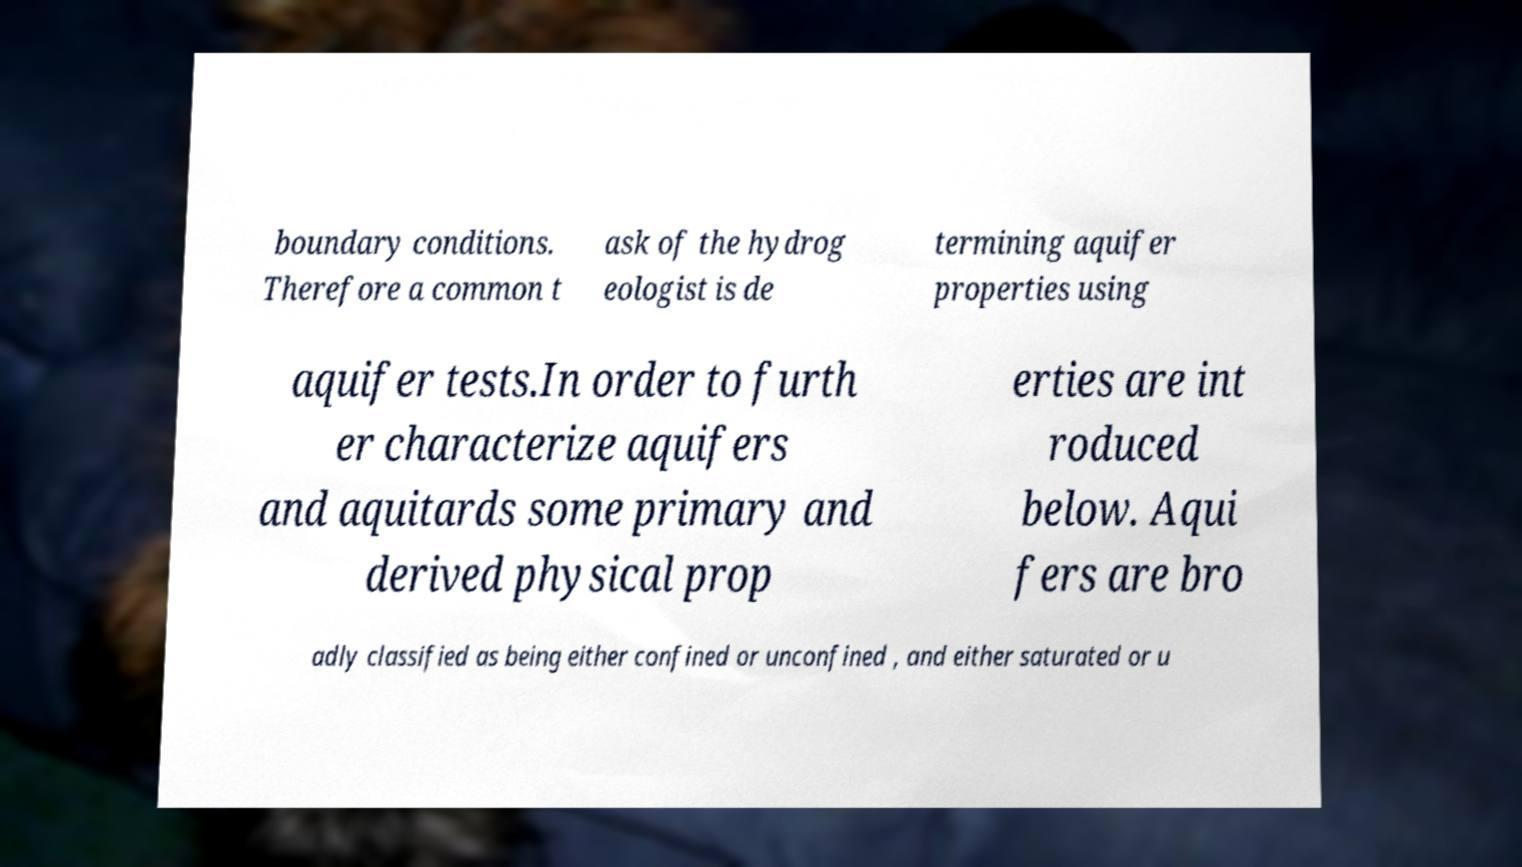Can you read and provide the text displayed in the image?This photo seems to have some interesting text. Can you extract and type it out for me? boundary conditions. Therefore a common t ask of the hydrog eologist is de termining aquifer properties using aquifer tests.In order to furth er characterize aquifers and aquitards some primary and derived physical prop erties are int roduced below. Aqui fers are bro adly classified as being either confined or unconfined , and either saturated or u 